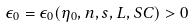Convert formula to latex. <formula><loc_0><loc_0><loc_500><loc_500>\epsilon _ { 0 } = \epsilon _ { 0 } ( \eta _ { 0 } , n , s , L , S C ) > 0</formula> 